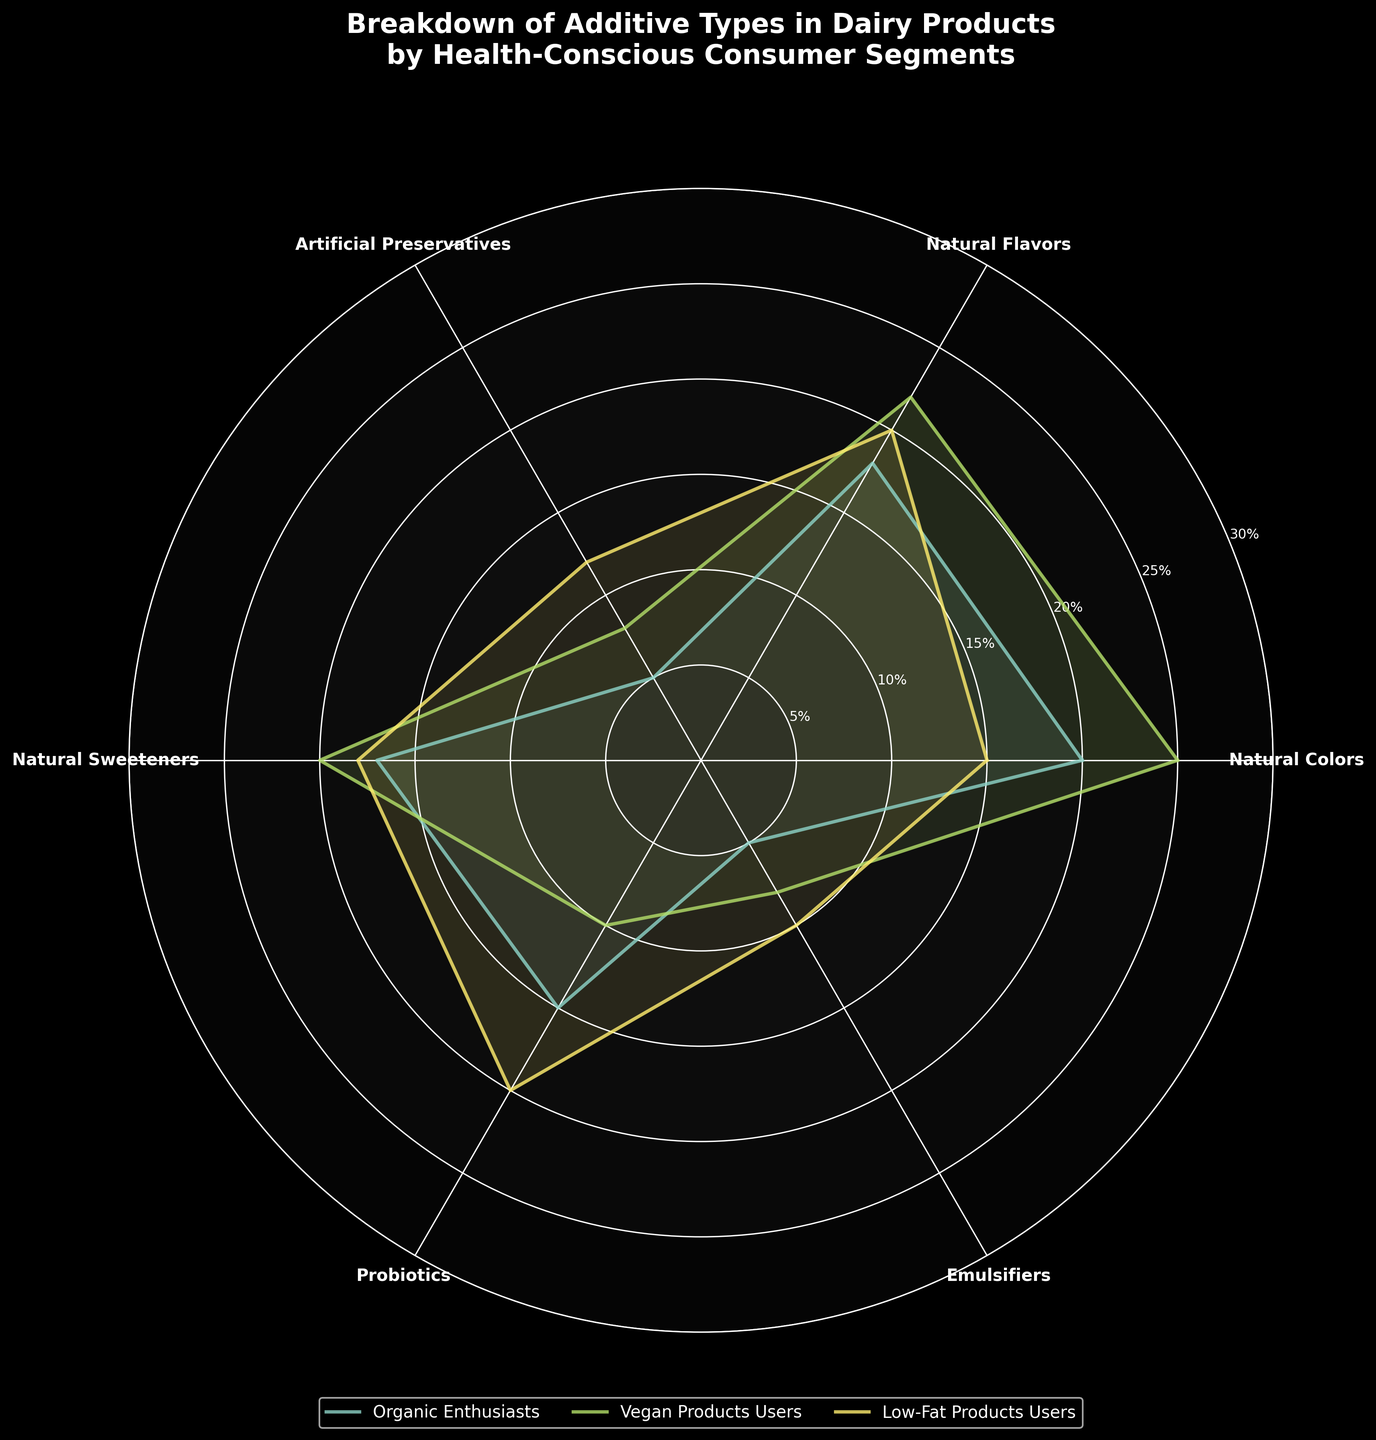How many segments are represented in the rose chart? The rose chart includes lines and areas for different health-conscious consumer segments. We can count the number of unique segments in the legend or visually distinguish the different colored areas in the plot
Answer: 3 Which segment has the highest percentage for Natural Colors? By looking at the "Natural Colors" section of the chart and comparing the heights of the corresponding areas for each segment, we can identify the tallest section. Here, the Vegan Products Users segment reaches the highest value
Answer: Vegan Products Users What is the range of percentages used on the y-axis? The y-axis has tick marks labeled with percentages, starting from the smallest to the largest. By identifying the first and last tick mark, we can determine the range of the y-axis
Answer: 0% to 30% Which additive type shows a higher percentage for Low-Fat Products Users compared to Organic Enthusiasts? By comparing the sections for Low-Fat Products Users and Organic Enthusiasts for each additive type, we look for where the Low-Fat Products Users' area is taller. Here, Artificial Preservatives and Probiotics fit this criterion
Answer: Artificial Preservatives, Probiotics Rank the consumer segments from highest to lowest percentage for Natural Sweeteners. By examining the Natural Sweeteners section and comparing the heights of areas for each segment, we can order them accordingly. The Vegan Products Users has the highest, followed by Low-Fat Products Users, and then Organic Enthusiasts
Answer: Vegan Products Users > Low-Fat Products Users > Organic Enthusiasts What is the average percentage of Natural Flavors across all segments? First, find the percentage values for Natural Flavors for each segment: 18% (Organic Enthusiasts), 22% (Vegan Products Users), and 20% (Low-Fat Products Users). Sum these values and divide by the number of segments: (18 + 22 + 20) / 3
Answer: 20% Which segment shows the least inclusion of Emulsifiers? By looking at the "Emulsifiers" section and comparing the smallest values across segments, we find that Organic Enthusiasts has the smallest section at 5%
Answer: Organic Enthusiasts Do Probiotics show more usage among Low-Fat Products Users or Vegan Products Users? By identifying the area for Probiotics corresponding to Low-Fat Products Users and Vegan Products Users and comparing their heights, we see that Low-Fat Products Users have a higher percentage
Answer: Low-Fat Products Users What is the difference between the highest and lowest percentage for Organic Enthusiasts across all additive types? Identify the maximum and minimum percentage values for Organic Enthusiasts across all additive types: 20% (Natural Colors) and 5% (Artificial Preservatives, Emulsifiers). Calculate the difference: 20% - 5%
Answer: 15% Which additive type shows a greater variance among the three segments? To determine this, visually compare the range of values (maximum - minimum) for each additive type across the three segments. For instance, Natural Colors has a variance of 25 - 15 = 10, and other types can be calculated similarly. The type with the highest variance is Natural Colors
Answer: Natural Colors 